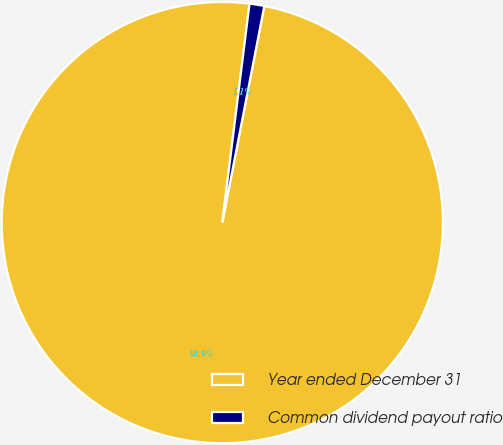Convert chart to OTSL. <chart><loc_0><loc_0><loc_500><loc_500><pie_chart><fcel>Year ended December 31<fcel>Common dividend payout ratio<nl><fcel>98.92%<fcel>1.08%<nl></chart> 